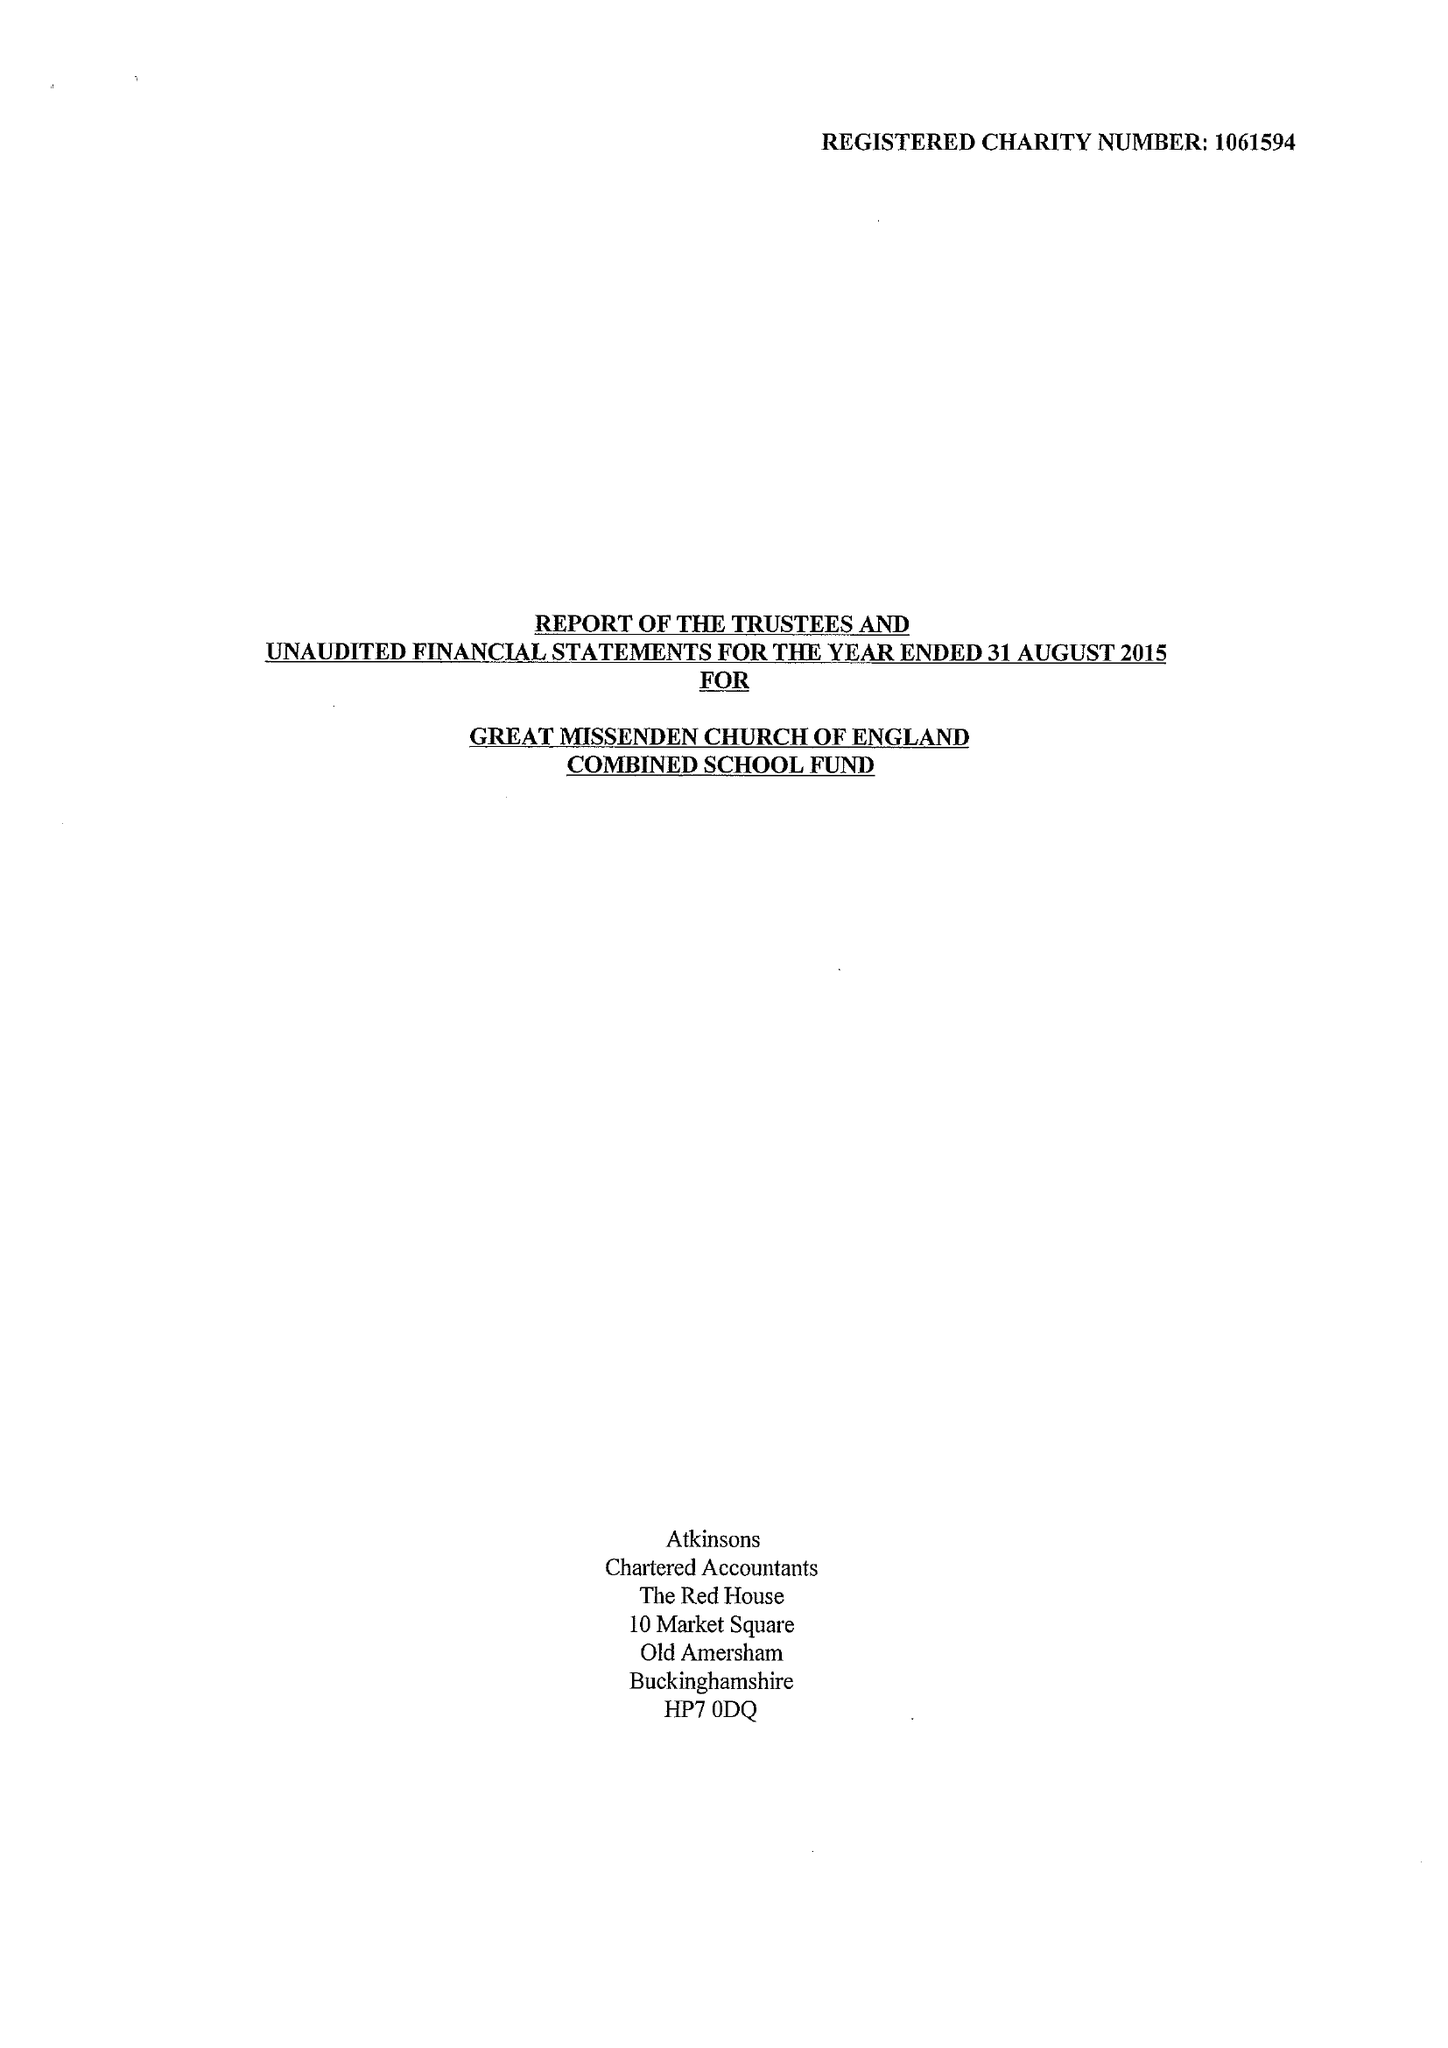What is the value for the charity_name?
Answer the question using a single word or phrase. Great Missenden C Of E Combined School Fund 